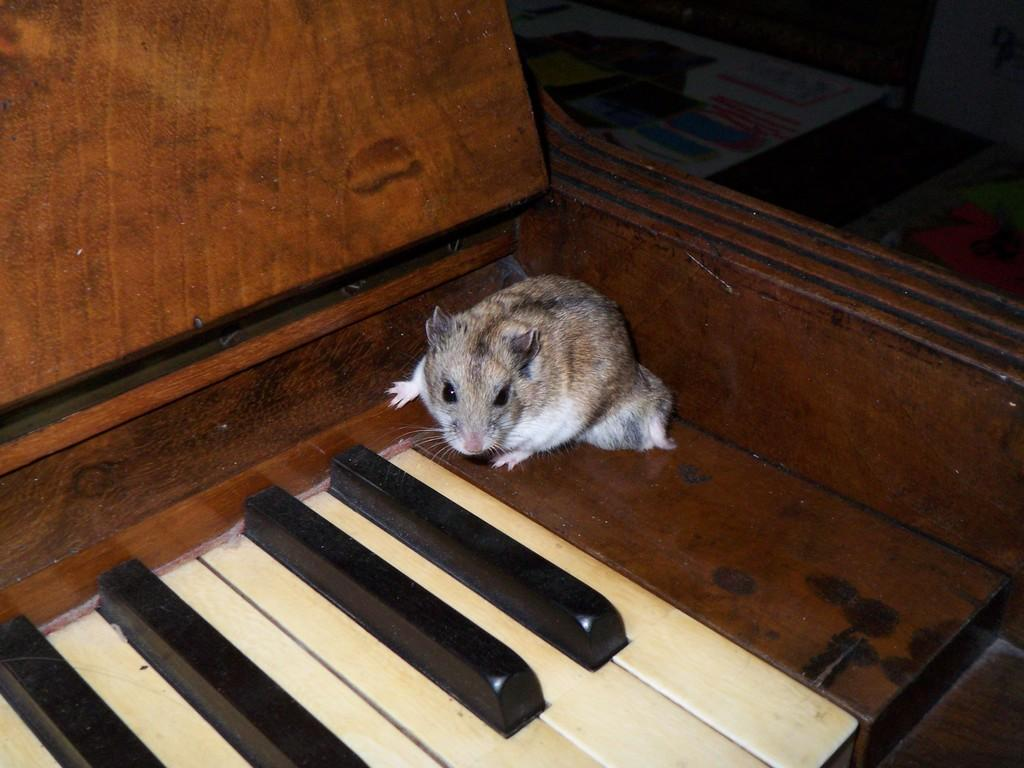What musical instrument can be seen in the image? There is a piano in the image. What unexpected creature is on the piano? A rat is present on the piano. What can be seen in the background of the image? There are boards visible in the background of the image. What type of print can be seen on the leaf in the image? There is no leaf or print present in the image; it only features a piano with a rat on it and boards in the background. 